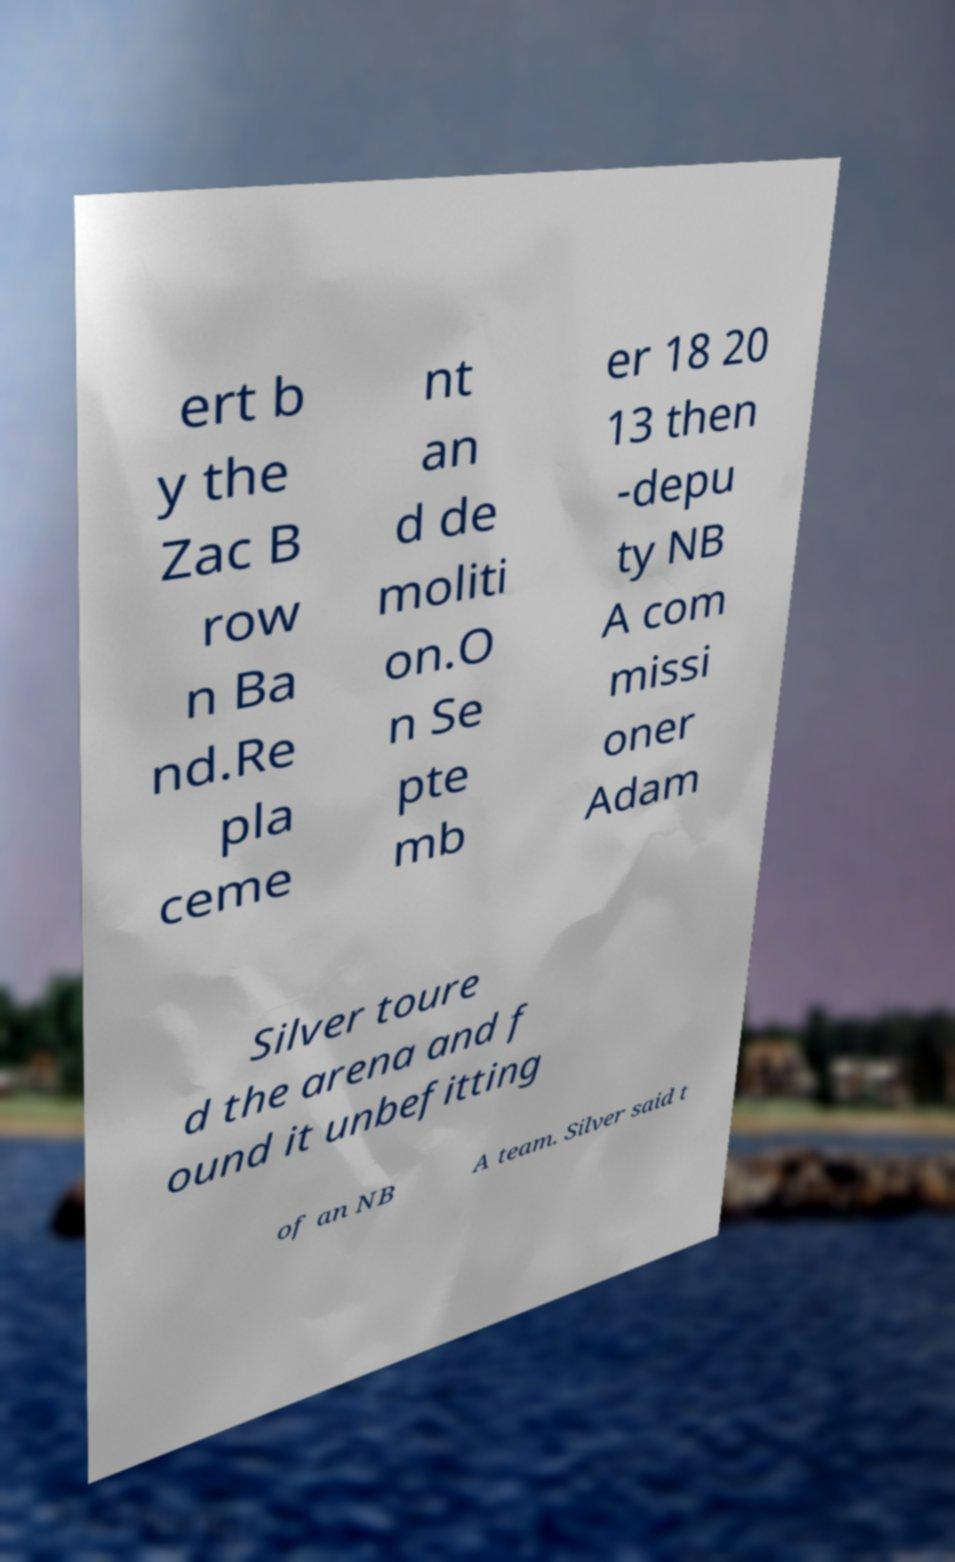What messages or text are displayed in this image? I need them in a readable, typed format. ert b y the Zac B row n Ba nd.Re pla ceme nt an d de moliti on.O n Se pte mb er 18 20 13 then -depu ty NB A com missi oner Adam Silver toure d the arena and f ound it unbefitting of an NB A team. Silver said t 